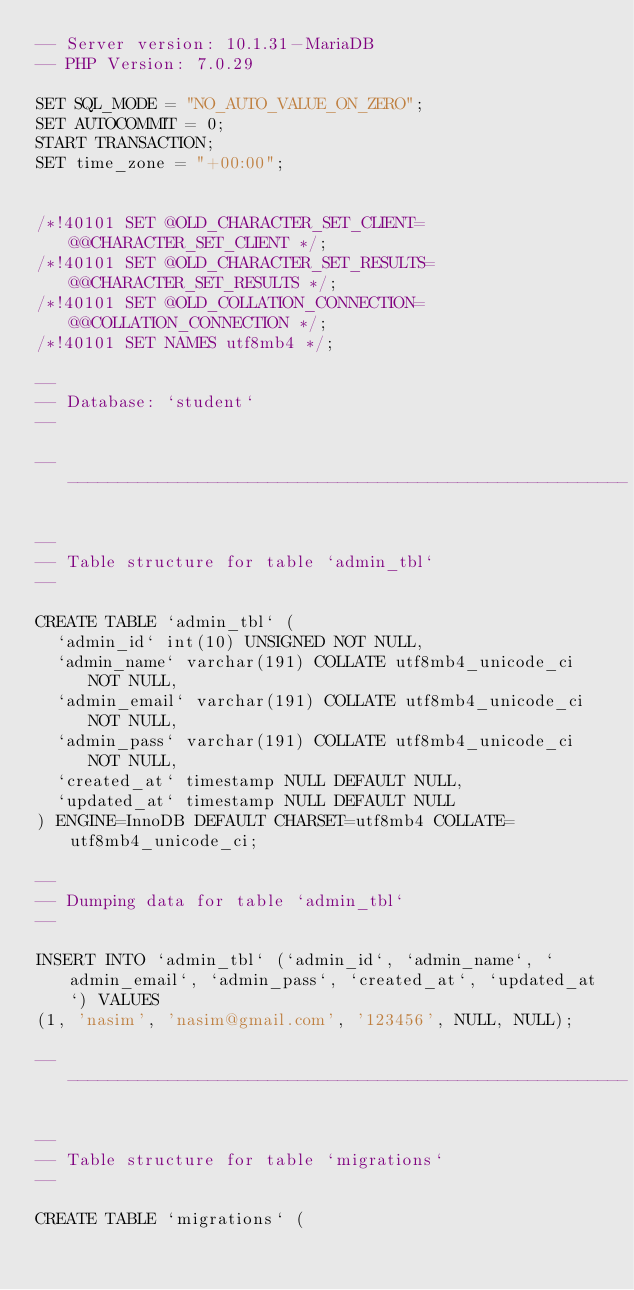<code> <loc_0><loc_0><loc_500><loc_500><_SQL_>-- Server version: 10.1.31-MariaDB
-- PHP Version: 7.0.29

SET SQL_MODE = "NO_AUTO_VALUE_ON_ZERO";
SET AUTOCOMMIT = 0;
START TRANSACTION;
SET time_zone = "+00:00";


/*!40101 SET @OLD_CHARACTER_SET_CLIENT=@@CHARACTER_SET_CLIENT */;
/*!40101 SET @OLD_CHARACTER_SET_RESULTS=@@CHARACTER_SET_RESULTS */;
/*!40101 SET @OLD_COLLATION_CONNECTION=@@COLLATION_CONNECTION */;
/*!40101 SET NAMES utf8mb4 */;

--
-- Database: `student`
--

-- --------------------------------------------------------

--
-- Table structure for table `admin_tbl`
--

CREATE TABLE `admin_tbl` (
  `admin_id` int(10) UNSIGNED NOT NULL,
  `admin_name` varchar(191) COLLATE utf8mb4_unicode_ci NOT NULL,
  `admin_email` varchar(191) COLLATE utf8mb4_unicode_ci NOT NULL,
  `admin_pass` varchar(191) COLLATE utf8mb4_unicode_ci NOT NULL,
  `created_at` timestamp NULL DEFAULT NULL,
  `updated_at` timestamp NULL DEFAULT NULL
) ENGINE=InnoDB DEFAULT CHARSET=utf8mb4 COLLATE=utf8mb4_unicode_ci;

--
-- Dumping data for table `admin_tbl`
--

INSERT INTO `admin_tbl` (`admin_id`, `admin_name`, `admin_email`, `admin_pass`, `created_at`, `updated_at`) VALUES
(1, 'nasim', 'nasim@gmail.com', '123456', NULL, NULL);

-- --------------------------------------------------------

--
-- Table structure for table `migrations`
--

CREATE TABLE `migrations` (</code> 